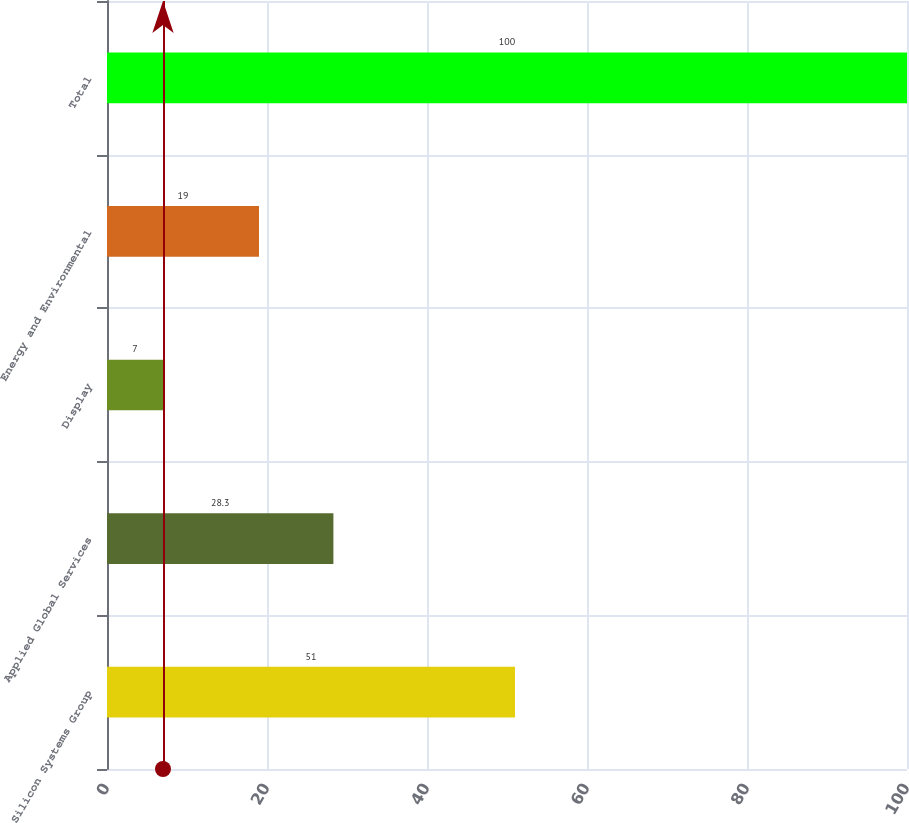Convert chart. <chart><loc_0><loc_0><loc_500><loc_500><bar_chart><fcel>Silicon Systems Group<fcel>Applied Global Services<fcel>Display<fcel>Energy and Environmental<fcel>Total<nl><fcel>51<fcel>28.3<fcel>7<fcel>19<fcel>100<nl></chart> 